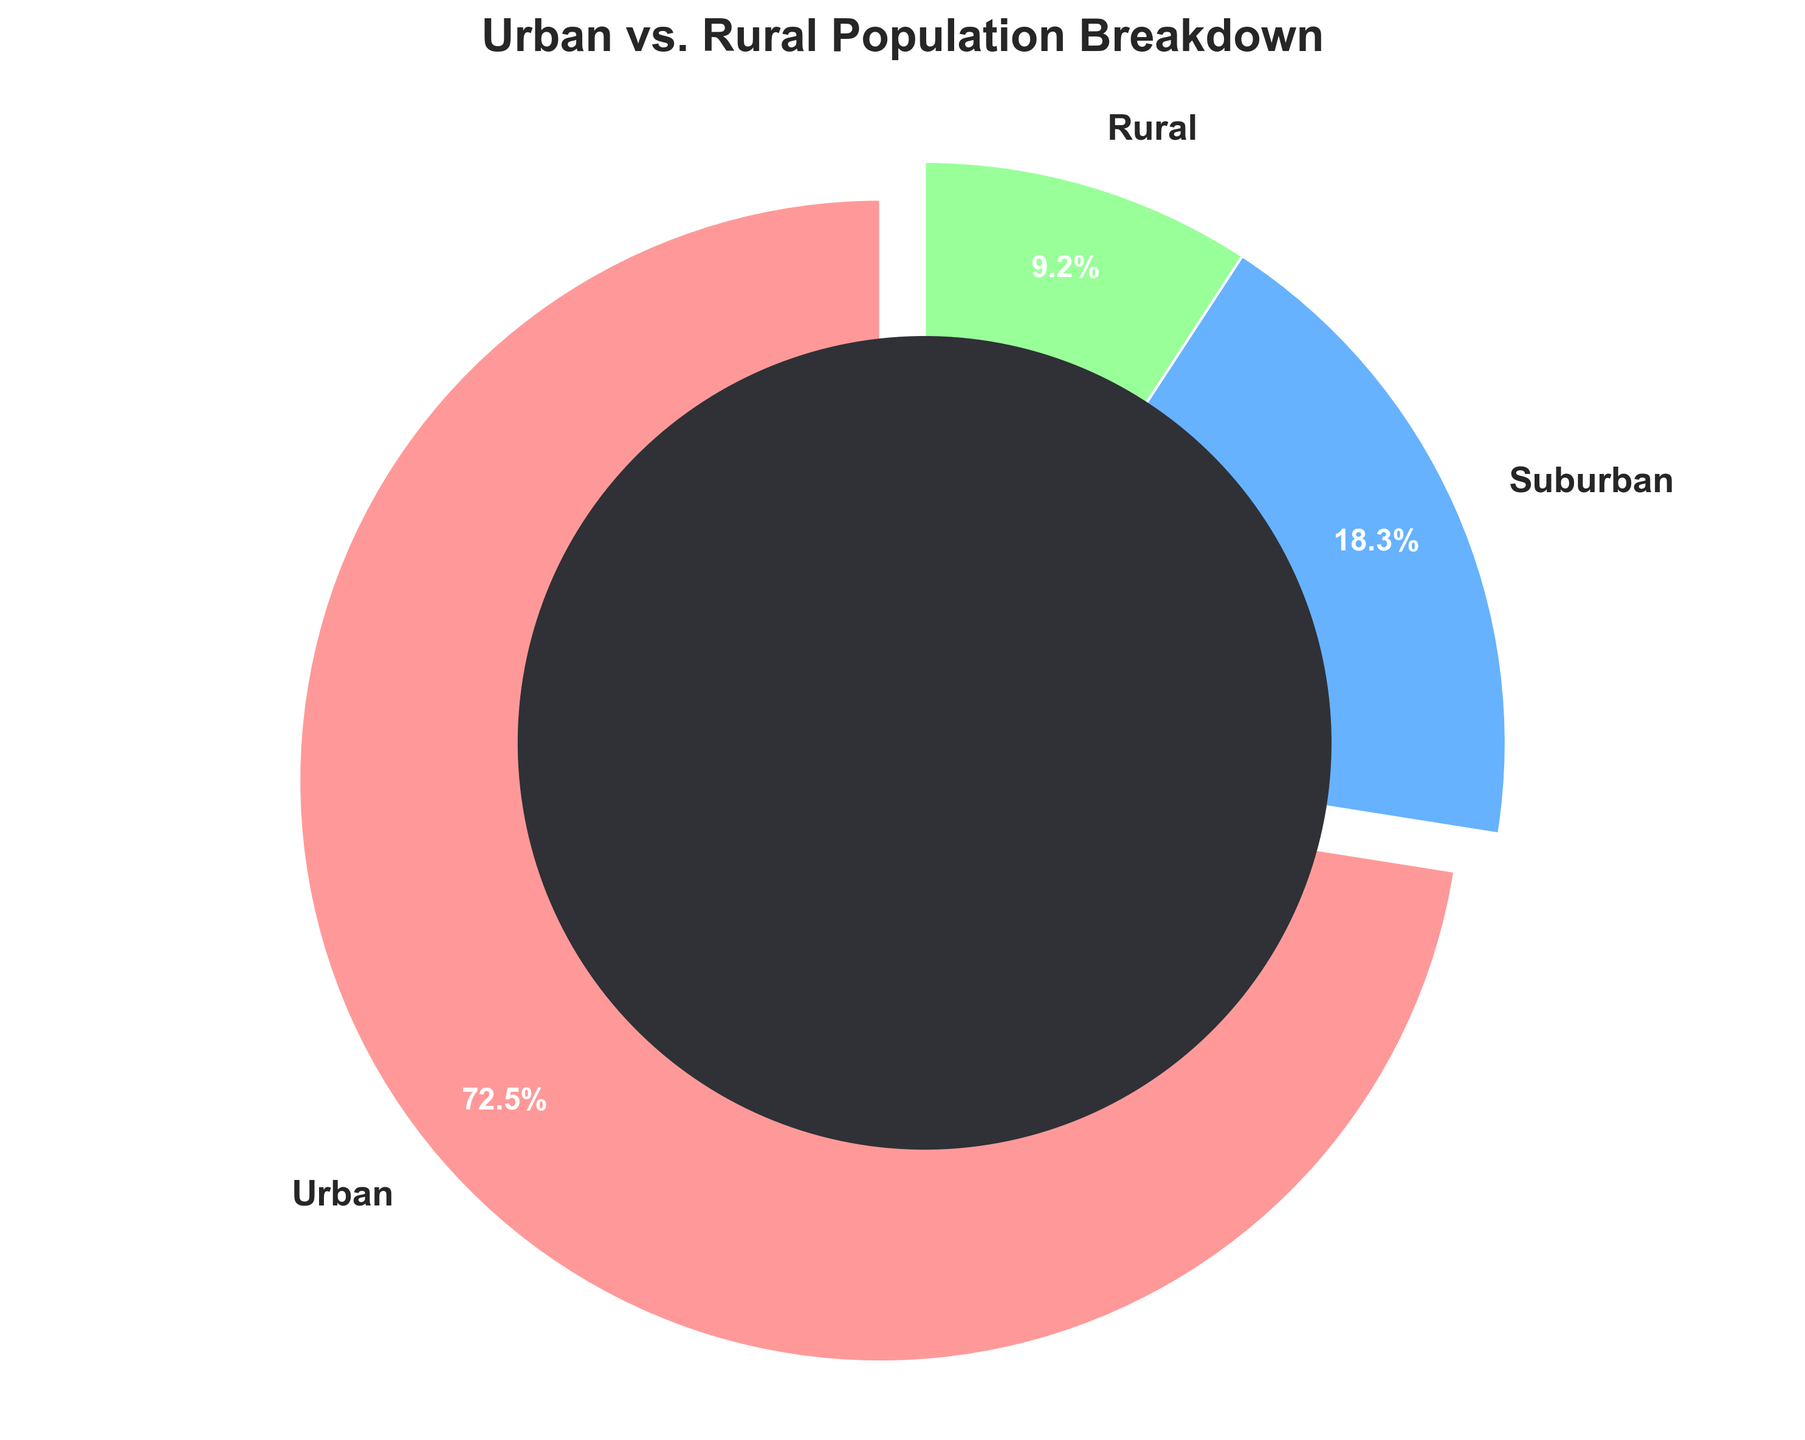What's the total percentage of non-urban population? To find the total percentage of non-urban population, we sum the percentages of suburban and rural populations. That is 18.3% + 9.2% = 27.5%.
Answer: 27.5% Which population type has the highest percentage? Looking at the pie chart, the largest segment represents the Urban population with 72.5%.
Answer: Urban How much greater is the urban population percentage compared to the rural population percentage? Subtract the rural percentage from the urban percentage: 72.5% - 9.2% = 63.3%.
Answer: 63.3% What colors represent the urban and rural populations? By referring to the color legend on the chart, the urban population is represented by red and the rural population by green.
Answer: Urban: red, Rural: green What is the percentage difference between suburban and rural populations? Subtract the rural percentage from the suburban percentage: 18.3% - 9.2% = 9.1%.
Answer: 9.1% Why might the urban population segment appear more prominent? The urban segment appears more prominent because it has the highest percentage value of 72.5%, which is visually larger in the pie chart.
Answer: Largest percentage What percentage of the population does not live in urban areas? By summing the suburban and rural percentages: 18.3% + 9.2% = 27.5%.
Answer: 27.5% Which population type is represented by the segment slightly exploded out from the pie chart? The exploded segment is highlighting the Urban population segment.
Answer: Urban By how much does the urban population exceed the combined suburban and rural population percentages? First, sum the suburban and rural percentages: 18.3% + 9.2% = 27.5%. Then subtract this from the urban percentage: 72.5% - 27.5% = 45%.
Answer: 45% What makes the rural population segment distinct in the chart? The rural population segment is visually smaller and green in color.
Answer: Small and green 